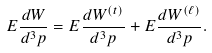<formula> <loc_0><loc_0><loc_500><loc_500>E \frac { d W } { d ^ { 3 } p } = E \frac { d W ^ { ( t ) } } { d ^ { 3 } p } + E \frac { d W ^ { ( \ell ) } } { d ^ { 3 } p } .</formula> 